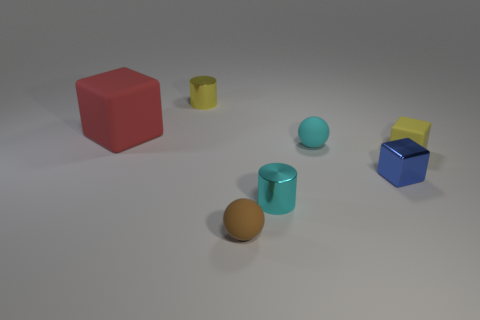How many metal objects are either cylinders or red objects?
Keep it short and to the point. 2. There is a tiny object that is both left of the cyan cylinder and behind the tiny rubber block; what is its color?
Your answer should be compact. Yellow. Do the rubber sphere that is behind the brown matte sphere and the small blue metallic thing have the same size?
Provide a succinct answer. Yes. What number of things are either tiny things that are behind the big block or red metal blocks?
Your answer should be very brief. 1. Are there any blue things of the same size as the brown object?
Make the answer very short. Yes. There is a brown thing that is the same size as the yellow rubber block; what is its material?
Keep it short and to the point. Rubber. What is the shape of the thing that is both right of the brown rubber sphere and in front of the small blue block?
Offer a very short reply. Cylinder. The tiny ball behind the small cyan cylinder is what color?
Provide a short and direct response. Cyan. There is a block that is both behind the small blue object and on the left side of the tiny yellow rubber object; what size is it?
Offer a very short reply. Large. Do the large cube and the sphere that is in front of the small yellow rubber block have the same material?
Make the answer very short. Yes. 